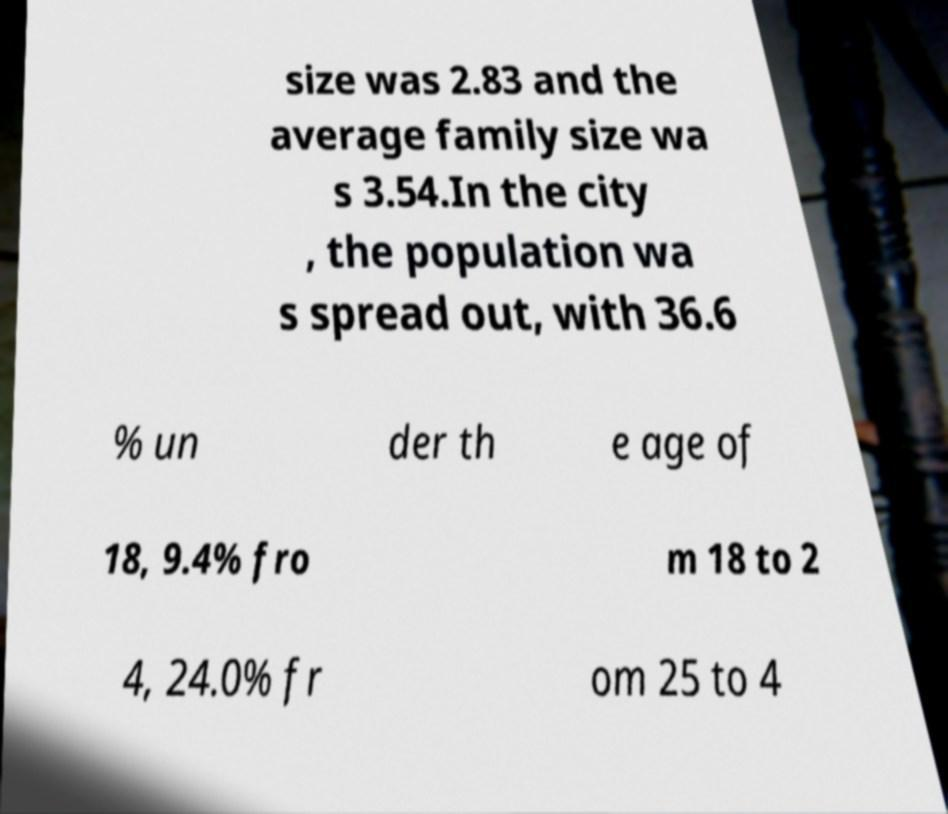There's text embedded in this image that I need extracted. Can you transcribe it verbatim? size was 2.83 and the average family size wa s 3.54.In the city , the population wa s spread out, with 36.6 % un der th e age of 18, 9.4% fro m 18 to 2 4, 24.0% fr om 25 to 4 